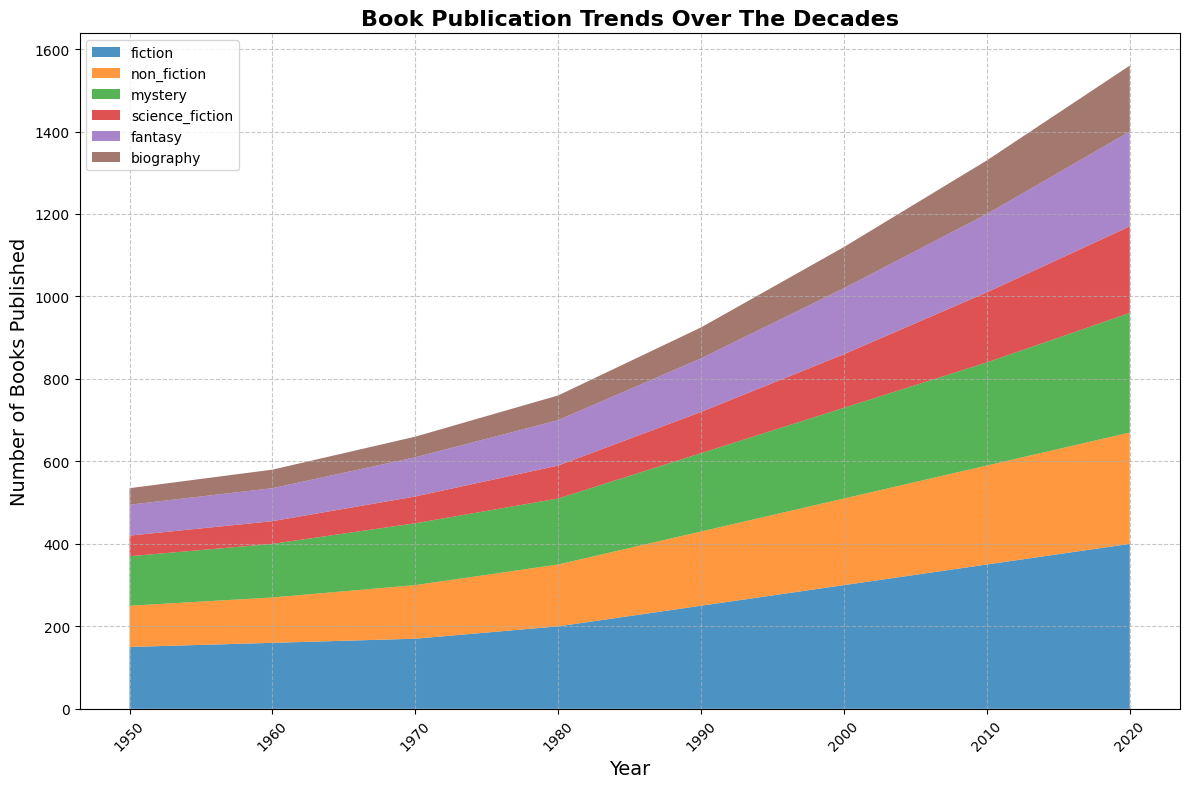What's the total number of books published across all genres in 2020? To find the total number of books published in 2020, add the number of books published in each genre for that year: 400 (fiction) + 270 (non-fiction) + 290 (mystery) + 210 (science fiction) + 230 (fantasy) + 160 (biography) = 1560
Answer: 1560 Which genre had the highest number of books published in 1980? Look at the 1980 segment in the area chart and identify the tallest segment and its corresponding genre. Fiction is the tallest, with 200 books.
Answer: Fiction How has the number of fantasy books published changed from 1950 to 2020? Calculate the difference in the number of fantasy books published between 2020 and 1950: 230 (2020) - 75 (1950) = 155.
Answer: Increased by 155 In which decade was the increase in the publication of science fiction books the highest? Compare the incremental changes across the decades for science fiction: 1950-1960 (+5), 1960-1970 (+10), 1970-1980 (+15), 1980-1990 (+20), 1990-2000 (+30), 2000-2010 (+40), 2010-2020 (+40). The largest increases were in 2000-2010 and 2010-2020.
Answer: 2000-2010 and 2010-2020 How do the publication trends of mystery and non-fiction books compare from 1990 to 2010? Calculate and compare the changes for mystery and non-fiction books from 1990 to 2010: Mystery: 250 (2010) - 190 (1990) = +60; Non-fiction: 240 (2010) - 180 (1990) = +60. Both genres showed an increase of 60 books each.
Answer: Both increased by 60 Which genre shows the most consistent increase over the decades? By visual inspection, observe which genre has a steadily rising area without dips or rapid changes. Fiction appears to have a consistent increase without any dramatic shifts.
Answer: Fiction What's the difference in the number of non-fiction and biography books published in 2020? Subtract the number of biography books from the number of non-fiction books in 2020: 270 (non-fiction) - 160 (biography) = 110.
Answer: 110 How many more fiction books were published in 2020 compared to 1950? Compare the numbers for fiction books in 2020 and 1950: 400 (2020) - 150 (1950) = 250.
Answer: 250 Out of all genres, which showed the largest growth in publication numbers from 1950 to 2020? Calculate the growth for each genre by subtracting the 1950 values from the 2020 values: Fiction: 400-150=250, Non-fiction: 270-100=170, Mystery: 290-120=170, Science Fiction: 210-50=160, Fantasy: 230-75=155, Biography: 160-40=120. Fiction shows the largest growth (250).
Answer: Fiction 